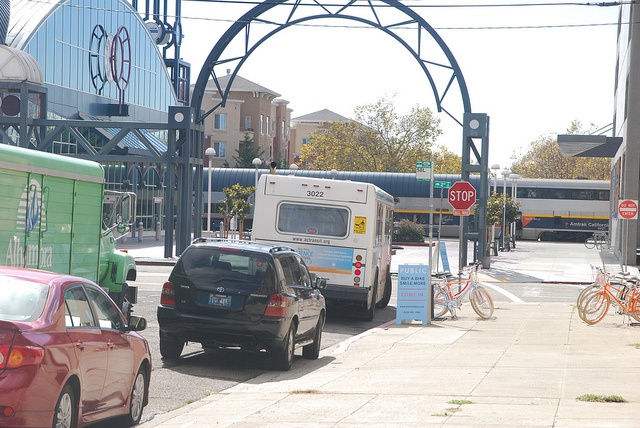Describe the objects in this image and their specific colors. I can see car in lightblue, brown, darkgray, gray, and lavender tones, car in lightblue, black, gray, and darkgray tones, truck in lightblue, darkgray, teal, and gray tones, truck in lightblue, lightgray, darkgray, gray, and black tones, and train in lightblue, darkgray, gray, darkblue, and black tones in this image. 